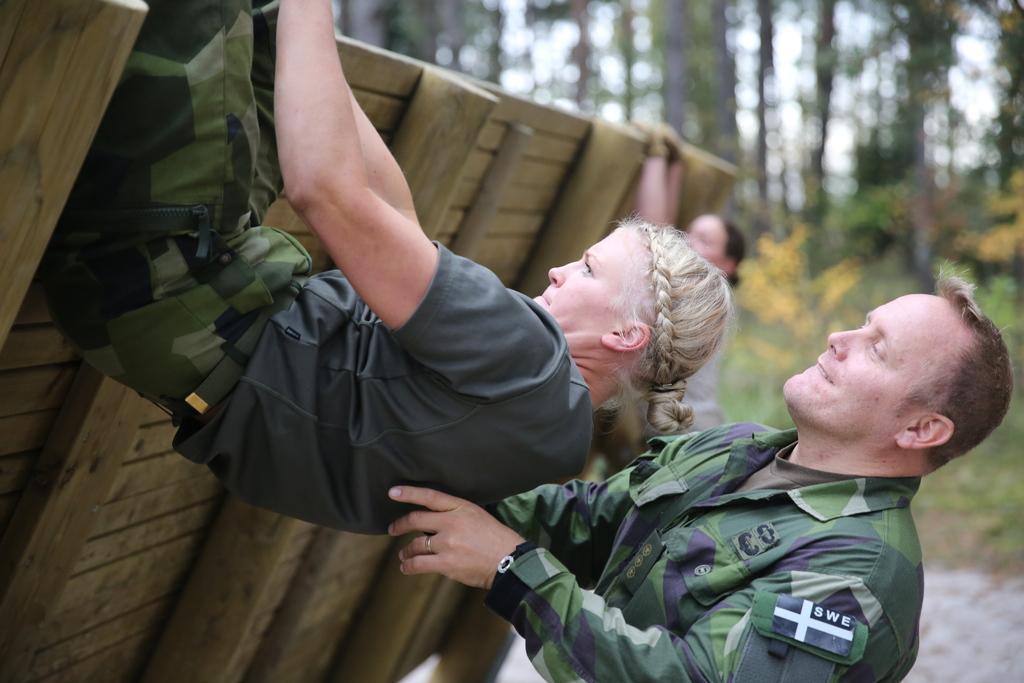Could you give a brief overview of what you see in this image? In this image I can see a woman wearing grey shirt and military pant and a person wearing military uniform. I can see a wooden wall which is brown in color. In the background I can see a person standing, few trees and the sky. 